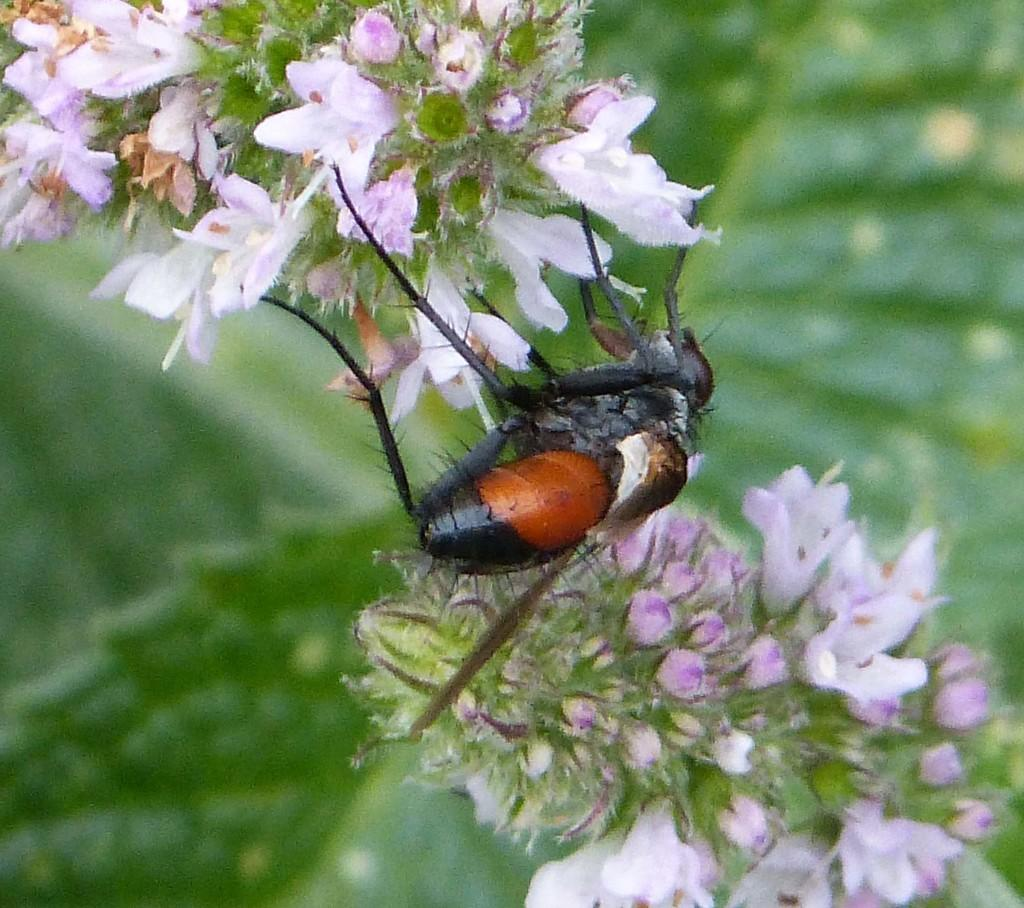What type of living organisms can be seen on the flowers in the image? There are insects visible on flowers in the image. What color is the background of the image? The background of the image is green. What type of plastic material can be seen in the image? There is no plastic material present in the image. What is the rate of the sun's movement in the image? The image is a still photograph and does not depict the movement of the sun or any other celestial bodies. 